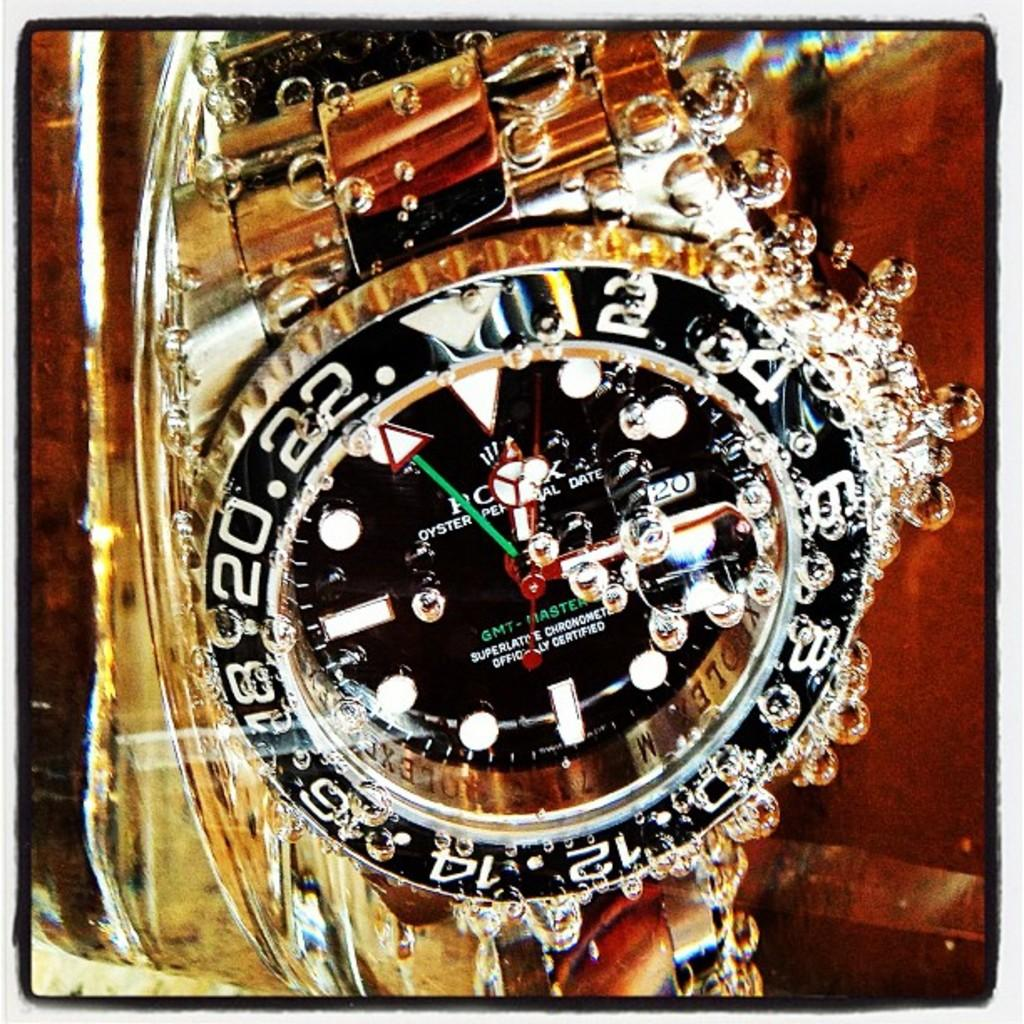<image>
Offer a succinct explanation of the picture presented. A gold Rolex brand watch that is submerged in water with air bubbles around it. 